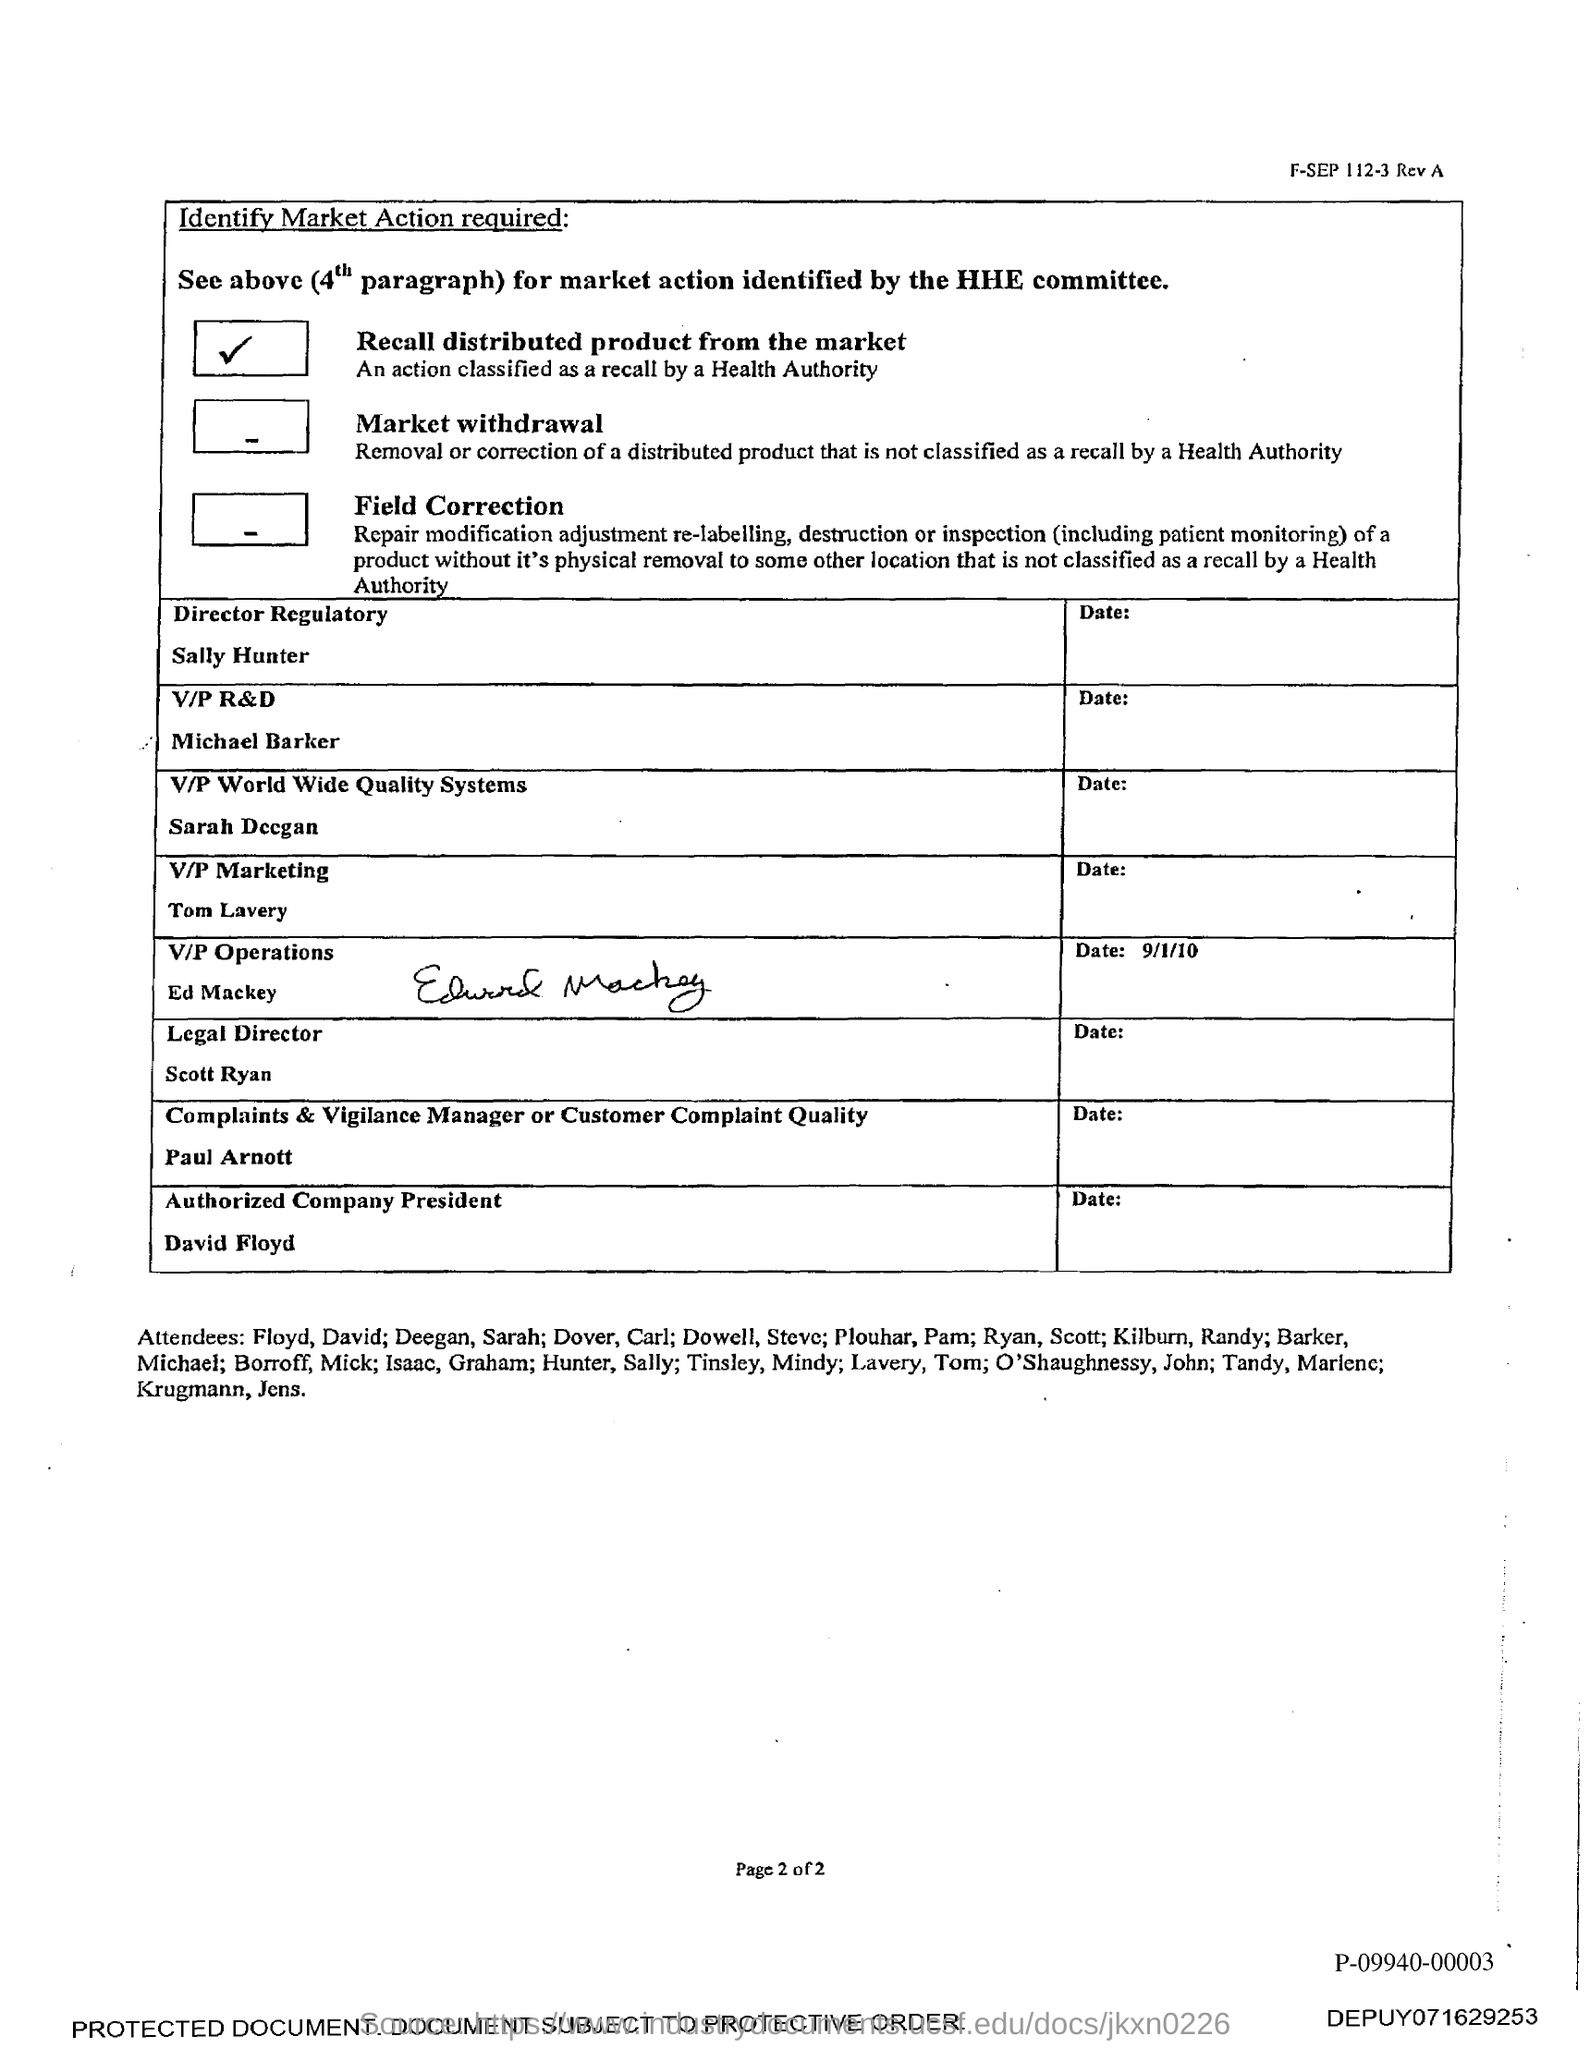Who is the Authorized Company President as per the document?
Give a very brief answer. David Floyd. What is the designation of Scott Ryan?
Ensure brevity in your answer.  Legal Director. What is the designation of Sally Hunter?
Offer a terse response. Director Regulatory. 